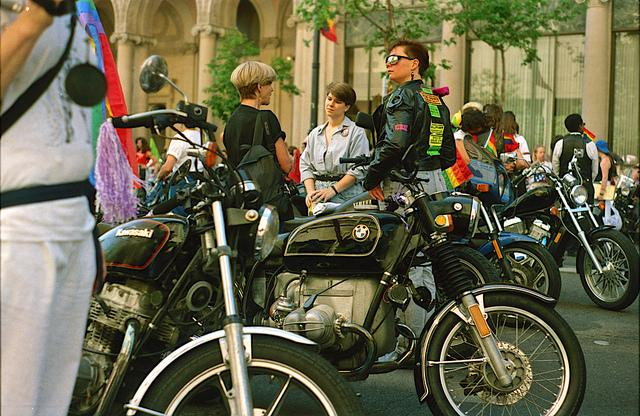What type of biking event is being held here? gay 